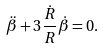Convert formula to latex. <formula><loc_0><loc_0><loc_500><loc_500>\ddot { \beta } + 3 \frac { \dot { R } } { R } \dot { \beta } = 0 .</formula> 